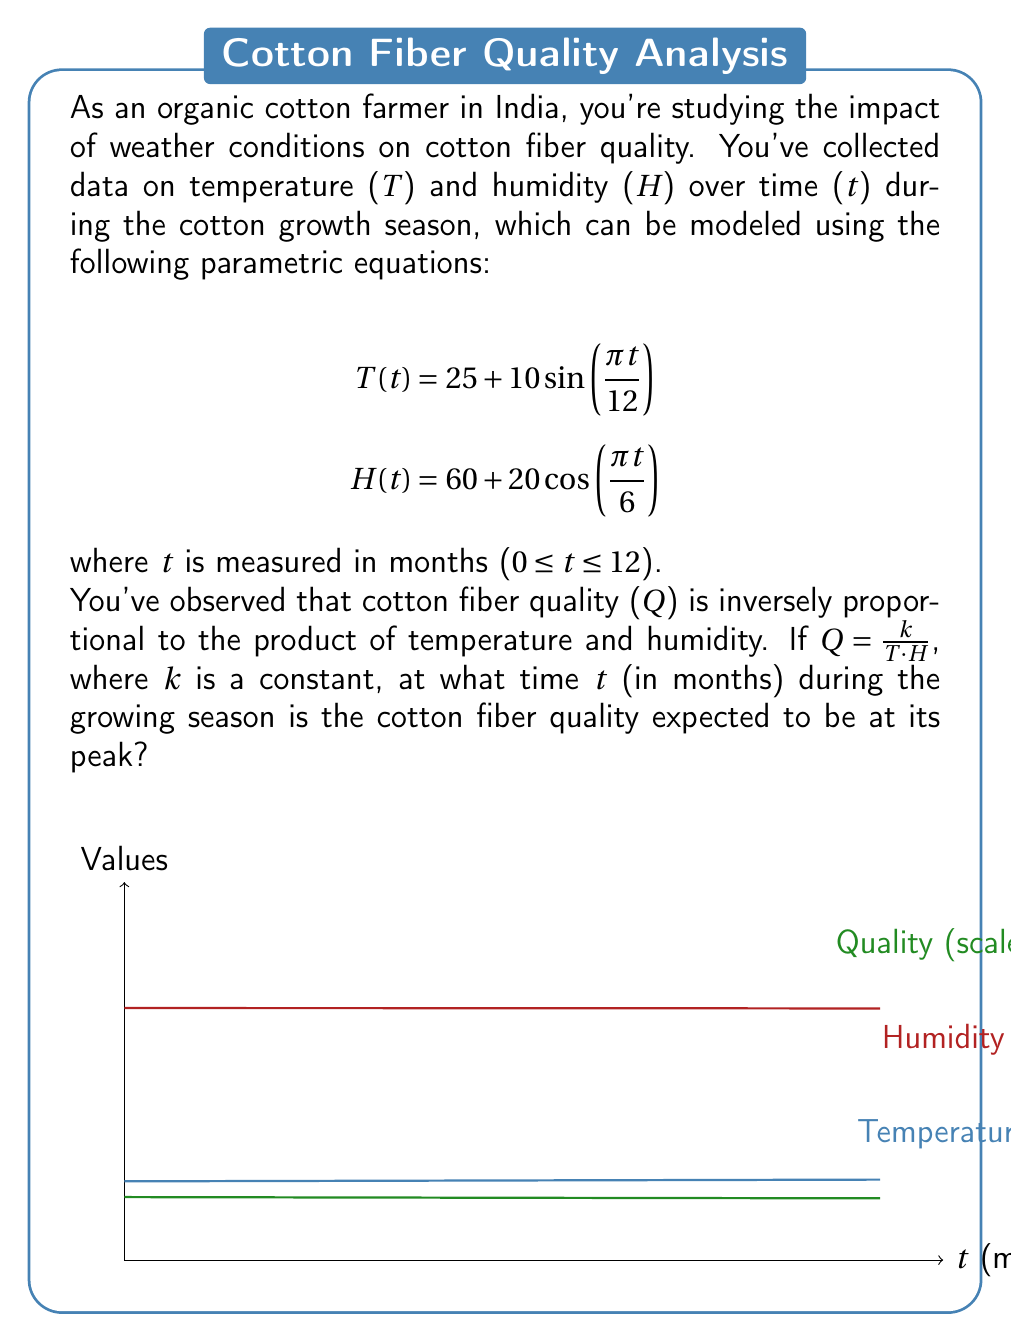Solve this math problem. To find the time when cotton fiber quality is at its peak, we need to determine when the product of temperature and humidity is at its minimum. Let's approach this step-by-step:

1) First, let's express the product of T and H as a function of t:

   $$P(t) = T(t) * H(t) = (25 + 10\sin(\frac{\pi t}{12})) * (60 + 20\cos(\frac{\pi t}{6}))$$

2) To find the minimum of P(t), we need to find where its derivative equals zero. However, this would lead to a complex trigonometric equation. Instead, let's consider the periods of T(t) and H(t):

   T(t) has a period of 24 months
   H(t) has a period of 12 months

3) The product P(t) will have a period of 24 months (the least common multiple of 24 and 12).

4) Within this 24-month cycle, T(t) will reach its maximum at t = 6 and its minimum at t = 18.
   H(t) will reach its maximum at t = 0, 12, 24 and its minimum at t = 6, 18.

5) Therefore, P(t) is likely to reach its minimum when both T(t) and H(t) are at or near their minimums, which occurs around t = 6 or t = 18.

6) Since we're only considering the first 12 months (0 ≤ t ≤ 12), the minimum of P(t), and thus the maximum of Q, should occur around t = 6.

7) To verify, we can calculate P(t) at t = 5, 6, and 7:

   P(5) ≈ 1941.96
   P(6) ≈ 1800.00
   P(7) ≈ 1941.96

Indeed, P(t) reaches its minimum at t = 6 months.
Answer: 6 months 